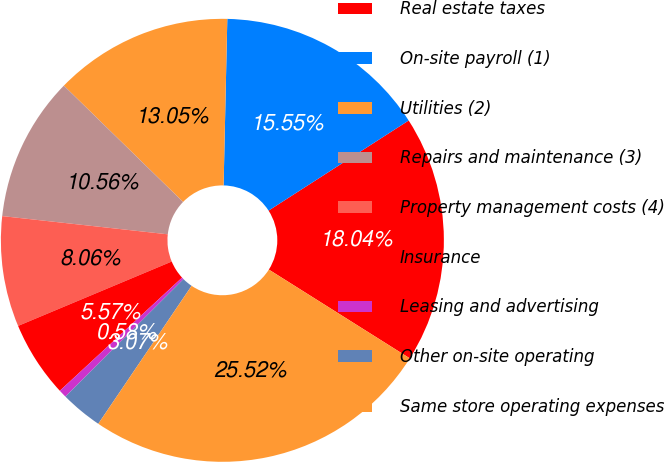Convert chart. <chart><loc_0><loc_0><loc_500><loc_500><pie_chart><fcel>Real estate taxes<fcel>On-site payroll (1)<fcel>Utilities (2)<fcel>Repairs and maintenance (3)<fcel>Property management costs (4)<fcel>Insurance<fcel>Leasing and advertising<fcel>Other on-site operating<fcel>Same store operating expenses<nl><fcel>18.04%<fcel>15.55%<fcel>13.05%<fcel>10.56%<fcel>8.06%<fcel>5.57%<fcel>0.58%<fcel>3.07%<fcel>25.52%<nl></chart> 